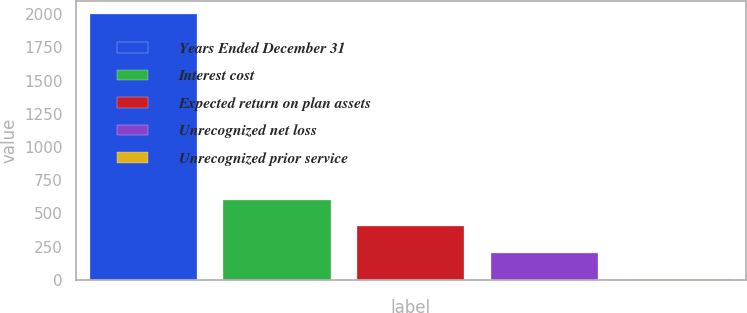Convert chart to OTSL. <chart><loc_0><loc_0><loc_500><loc_500><bar_chart><fcel>Years Ended December 31<fcel>Interest cost<fcel>Expected return on plan assets<fcel>Unrecognized net loss<fcel>Unrecognized prior service<nl><fcel>2003<fcel>603<fcel>403<fcel>203<fcel>3<nl></chart> 